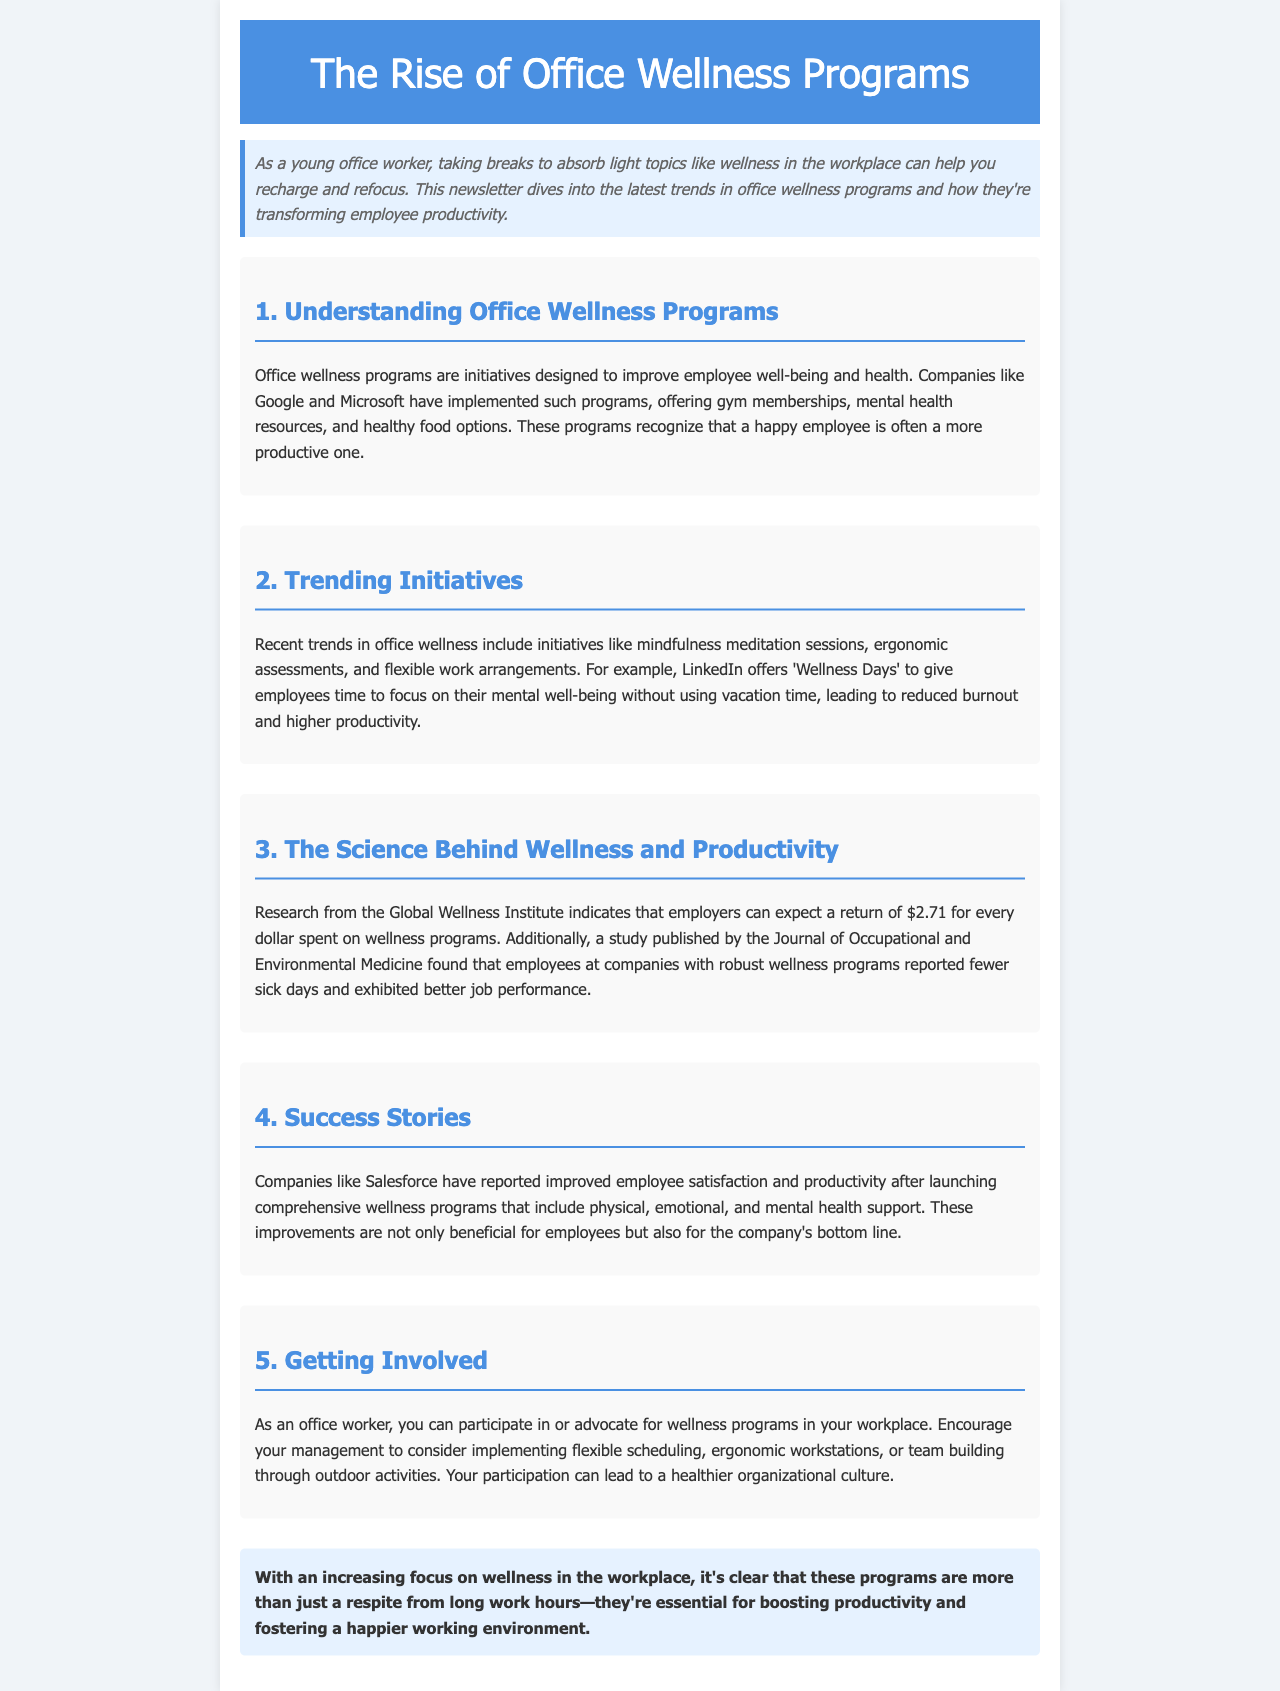What are office wellness programs? Office wellness programs are initiatives designed to improve employee well-being and health.
Answer: Initiatives designed to improve employee well-being and health Which companies are mentioned as having implemented wellness programs? The document mentions companies like Google and Microsoft as examples of those implementing wellness programs.
Answer: Google and Microsoft What is one trending initiative in office wellness programs? The document lists mindfulness meditation sessions as one of the trending initiatives.
Answer: Mindfulness meditation sessions How much can employers expect to return for every dollar spent on wellness programs? The document states that employers can expect a return of $2.71 for every dollar spent on wellness programs.
Answer: $2.71 What have companies like Salesforce reported after launching wellness programs? According to the document, Salesforce has reported improved employee satisfaction and productivity.
Answer: Improved employee satisfaction and productivity What was the unique offering by LinkedIn in their wellness initiatives? LinkedIn offers 'Wellness Days' to give employees time to focus on their mental well-being.
Answer: 'Wellness Days' What can office workers do to get involved in wellness programs? Office workers can participate in or advocate for wellness programs in their workplace.
Answer: Participate in or advocate for wellness programs What does the conclusion of the newsletter emphasize about wellness programs? The conclusion emphasizes that these programs are essential for boosting productivity and fostering a happier working environment.
Answer: Essential for boosting productivity and fostering a happier working environment 